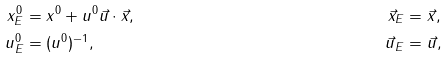Convert formula to latex. <formula><loc_0><loc_0><loc_500><loc_500>x ^ { 0 } _ { E } & = x ^ { 0 } + u ^ { 0 } \vec { u } \cdot \vec { x } , & \vec { x } _ { E } & = \vec { x } , \\ u ^ { 0 } _ { E } & = ( u ^ { 0 } ) ^ { - 1 } , & \vec { u } _ { E } & = \vec { u } ,</formula> 